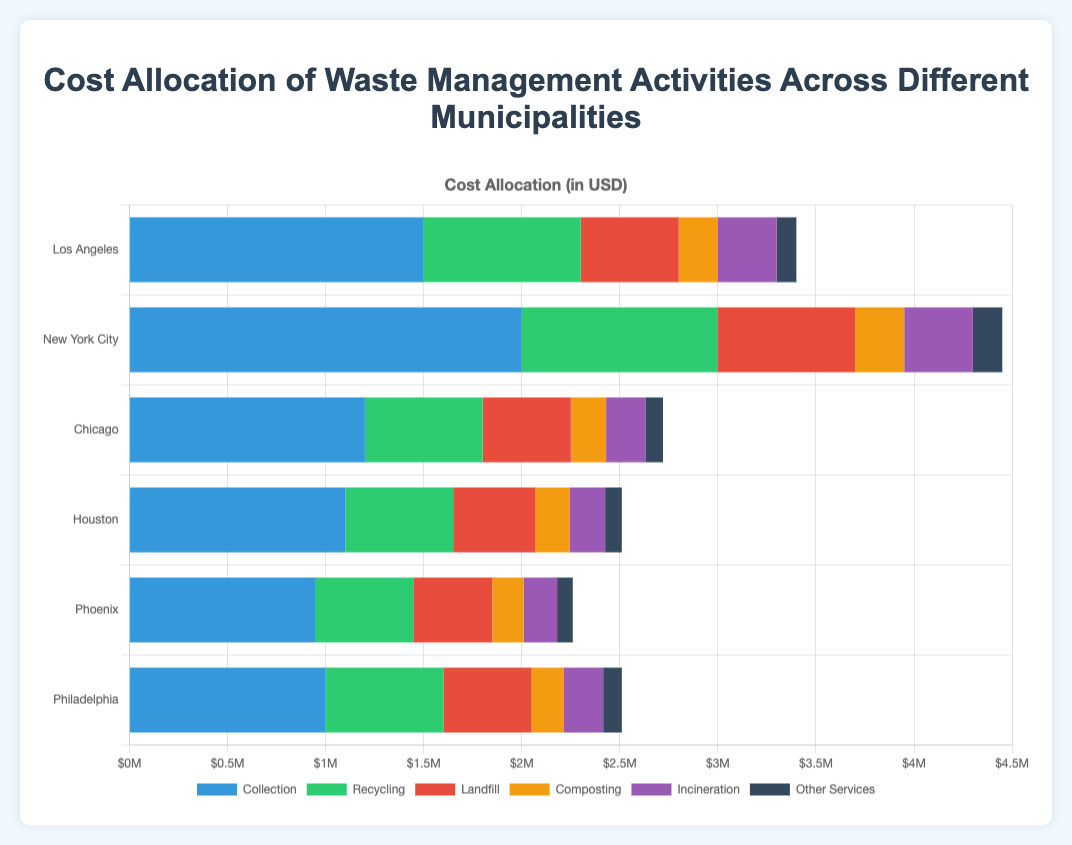What is the total cost allocated to waste management activities in Los Angeles? To find the total cost, sum up all the activities' costs: Collection (1,500,000) + Recycling (800,000) + Landfill (500,000) + Composting (200,000) + Incineration (300,000) + Other Services (100,000) = 3,400,000 USD.
Answer: 3,400,000 USD Which municipality spends the most on recycling? Compare the recycling costs across all municipalities: Los Angeles (800,000), New York City (1,000,000), Chicago (600,000), Houston (550,000), Phoenix (500,000), Philadelphia (600,000). The highest value is 1,000,000 in New York City.
Answer: New York City What is the difference in cost between the incineration activities of Houston and Phoenix? Subtract the cost of incineration in Phoenix from that in Houston: Houston (180,000) - Phoenix (170,000) = 10,000 USD.
Answer: 10,000 USD Which municipality allocates the least amount to other services, and how much is it? Compare the costs allocated to other services: Los Angeles (100,000), New York City (150,000), Chicago (90,000), Houston (85,000), Phoenix (80,000), Philadelphia (95,000). The least value is 80,000 in Phoenix.
Answer: Phoenix, 80,000 USD What is the average cost of composting activities across all municipalities? Calculate the average cost: Sum the composting costs: Los Angeles (200,000) + New York City (250,000) + Chicago (180,000) + Houston (175,000) + Phoenix (160,000) + Philadelphia (165,000) = 1,130,000. Divide by the number of municipalities (6): 1,130,000 / 6 = 188,333.33 USD.
Answer: 188,333.33 USD Which municipality spends more on landfill activities, Chicago or Philadelphia, and by how much? Compare the landfill costs of Chicago (450,000) and Philadelphia (450,000). Both municipalities spend the same amount.
Answer: Equal How does the total cost allocated to waste management activities in New York City compare to that in Houston? First, calculate the total costs: New York City: Collection (2,000,000) + Recycling (1,000,000) + Landfill (700,000) + Composting (250,000) + Incineration (350,000) + Other Services (150,000) = 4,450,000 USD. Houston: Collection (1,100,000) + Recycling (550,000) + Landfill (420,000) + Composting (175,000) + Incineration (180,000) + Other Services (85,000) = 2,510,000 USD. Now, find the difference: 4,450,000 - 2,510,000 = 1,940,000 USD.
Answer: New York City spends 1,940,000 USD more than Houston 